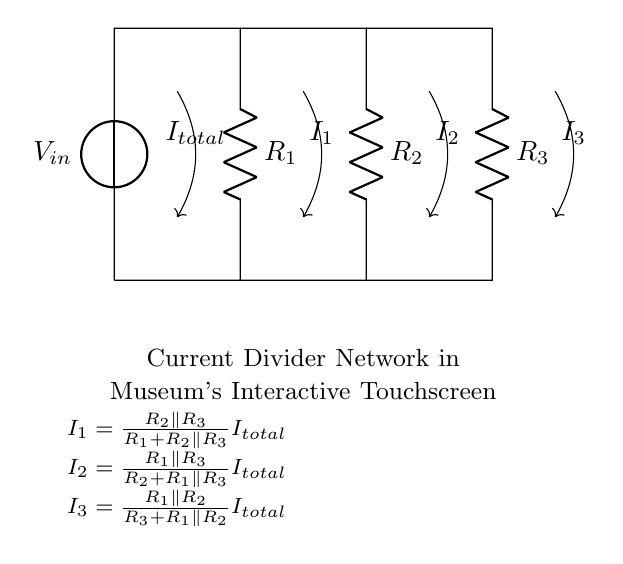What is the total current entering the circuit? The total current, denoted as I total, is represented by the arrow pointing into the circuit diagram from the voltage source. It shows the cumulative current supplied by the source before it divides among the different branches.
Answer: I total How many resistors are in the circuit? There are three resistors visible in the circuit diagram, labeled R1, R2, and R3, each connected in parallel off the main line after the voltage source.
Answer: Three Which resistor has the largest impact on current division? R1 impacts current division the most because it is in series with the total current and determines the total resistance seen by the other branches, affecting the division among R2 and R3.
Answer: R1 What is the formula for current through resistor R2? The formula for the current through R2 is derived from the current divider rule, which includes the resistances of R1, R2, and R3. The formula shown below the circuit clarifies how the current is calculated, specifically focusing on R2's contribution in the context of total current and resistance values.
Answer: I2 = R1 parallel R3 / (R2 + R1 parallel R3) I total How does the current through resistor R3 compare to that through resistor R2? The current through R3 can be calculated using the current divider principle for this circuit, which shows that R3's current depends on the resistance values relative to R2; thus, a higher resistance in R2 leads to less current flowing through R3. This relationship illustrates that as one resistor's value increases, the other's current may decrease correspondingly.
Answer: Depends on resistances What type of circuit configuration is displayed? The circuit configuration is a current divider network, which allows current to split across multiple parallel branches according to their resistances, leading to different currents flowing through each branch. This is essential for understanding how the energy is distributed in the interactive touchscreen display context.
Answer: Current divider Which two resistors are in parallel calculating current I1? The calculation for current I1 specifically involves resistors R2 and R3, as indicated in the formula provided; this relationship shows how their combined effect influences the total current division, primarily contributing to the amount of current bypassing R1.
Answer: R2 and R3 